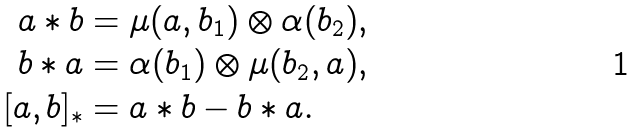Convert formula to latex. <formula><loc_0><loc_0><loc_500><loc_500>a * b & = \mu ( a , b _ { 1 } ) \otimes \alpha ( b _ { 2 } ) , \\ b * a & = \alpha ( b _ { 1 } ) \otimes \mu ( b _ { 2 } , a ) , \\ [ a , b ] _ { * } & = a * b - b * a .</formula> 